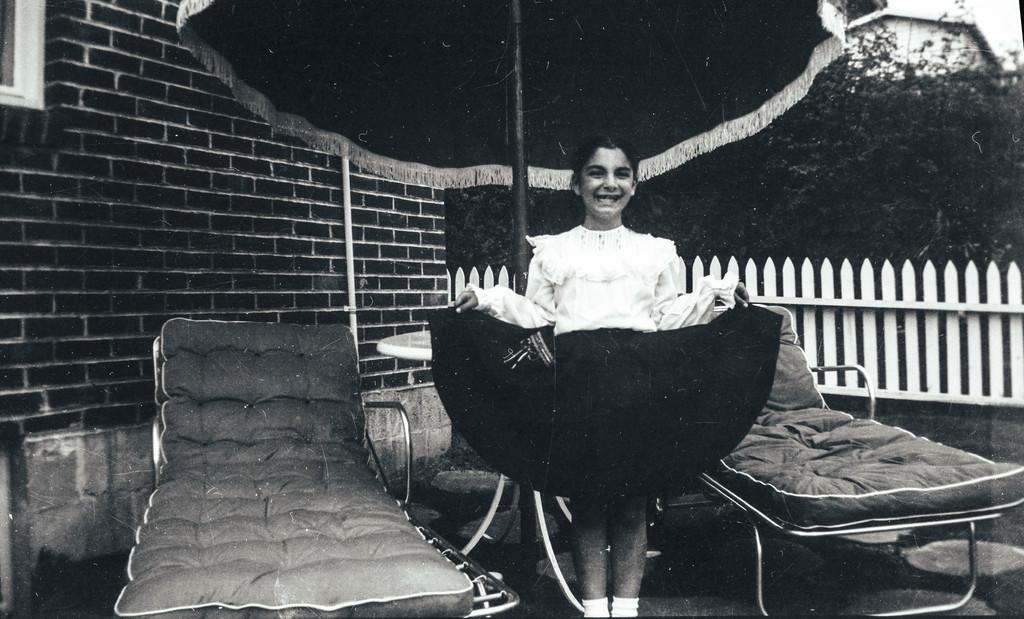Describe this image in one or two sentences. In the middle of the image a girl is standing and smiling. Behind her there are some chairs and tables and fencing and there is a building. At the top of the image there is an umbrella. Behind the umbrella there are some trees. 